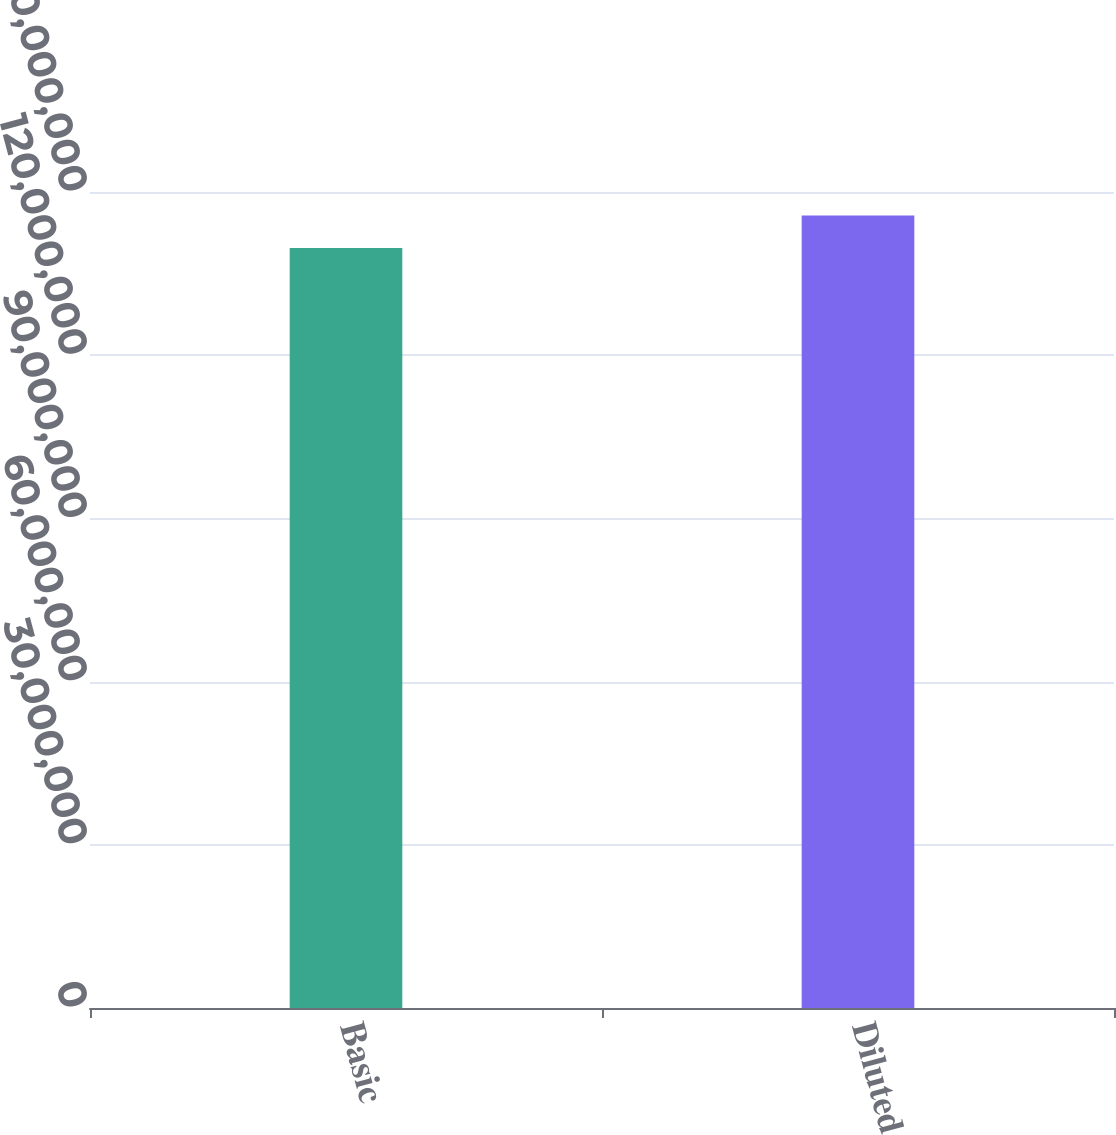Convert chart to OTSL. <chart><loc_0><loc_0><loc_500><loc_500><bar_chart><fcel>Basic<fcel>Diluted<nl><fcel>1.39688e+08<fcel>1.45672e+08<nl></chart> 